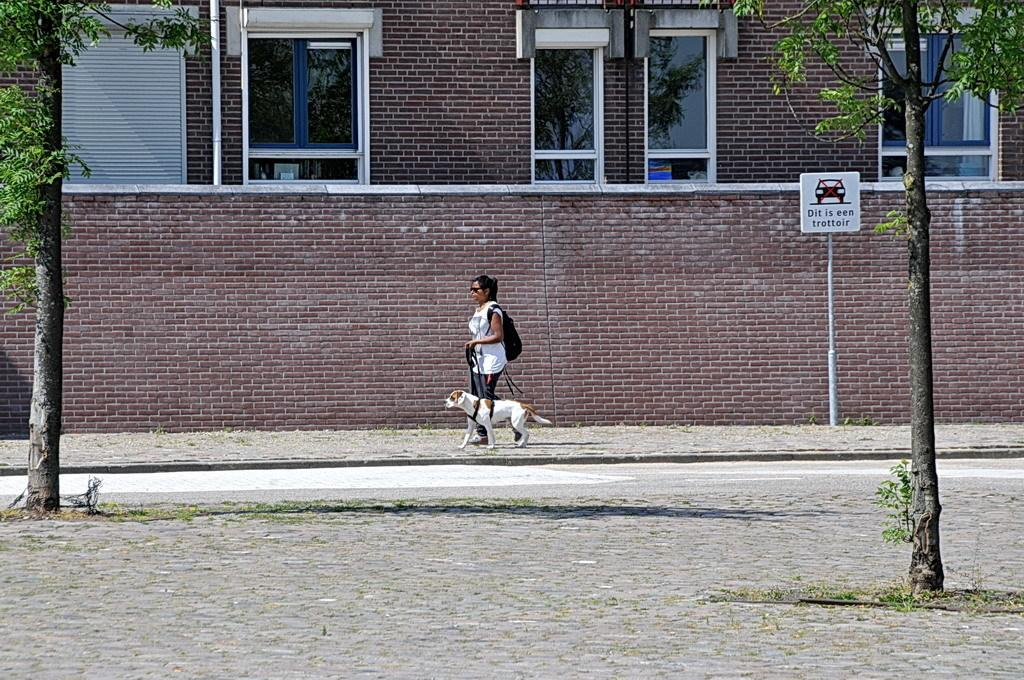Who is present in the image? There is a woman in the image. What is the woman holding in the image? The woman is holding a belt tied to a dog. What is the woman wearing in the image? The woman is wearing a bag. What structure can be seen in the image? There is a board attached to a pole in the image. What type of natural environment is visible in the image? Trees are visible in the image. What architectural feature can be seen in the image? There are windows in the image. What man-made feature is present in the image? A road is present in the image. What type of building is visible in the image? There is a building in the image. What company does the queen represent in the image? There is no queen or company present in the image. What type of currency exchange is taking place in the image? There is no currency exchange or any indication of a transaction in the image. 